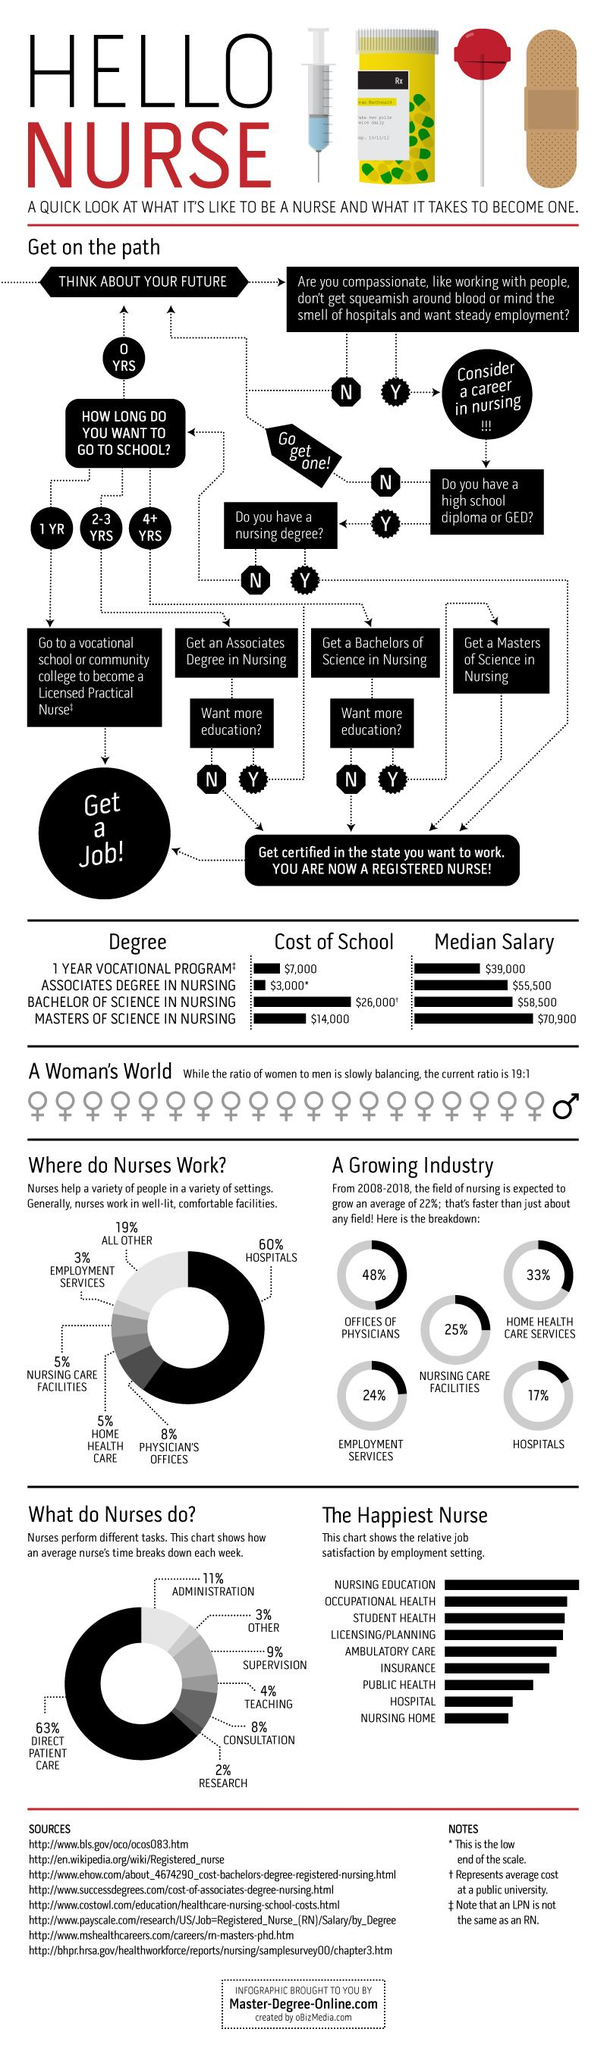Identify some key points in this picture. The type of work with the highest share is hospitals. The task that a nurse is responsible for performing that has the highest share is direct patient care. The total percentage of teaching and consultation is 11%. 